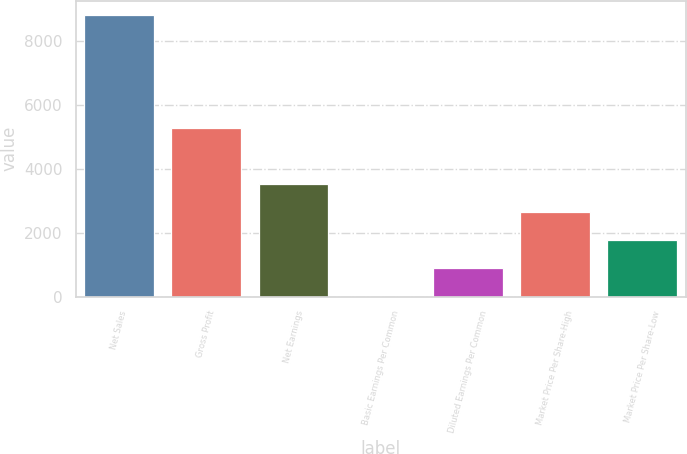Convert chart. <chart><loc_0><loc_0><loc_500><loc_500><bar_chart><fcel>Net Sales<fcel>Gross Profit<fcel>Net Earnings<fcel>Basic Earnings Per Common<fcel>Diluted Earnings Per Common<fcel>Market Price Per Share-High<fcel>Market Price Per Share-Low<nl><fcel>8826<fcel>5282.1<fcel>3530.91<fcel>0.83<fcel>883.35<fcel>2648.39<fcel>1765.87<nl></chart> 